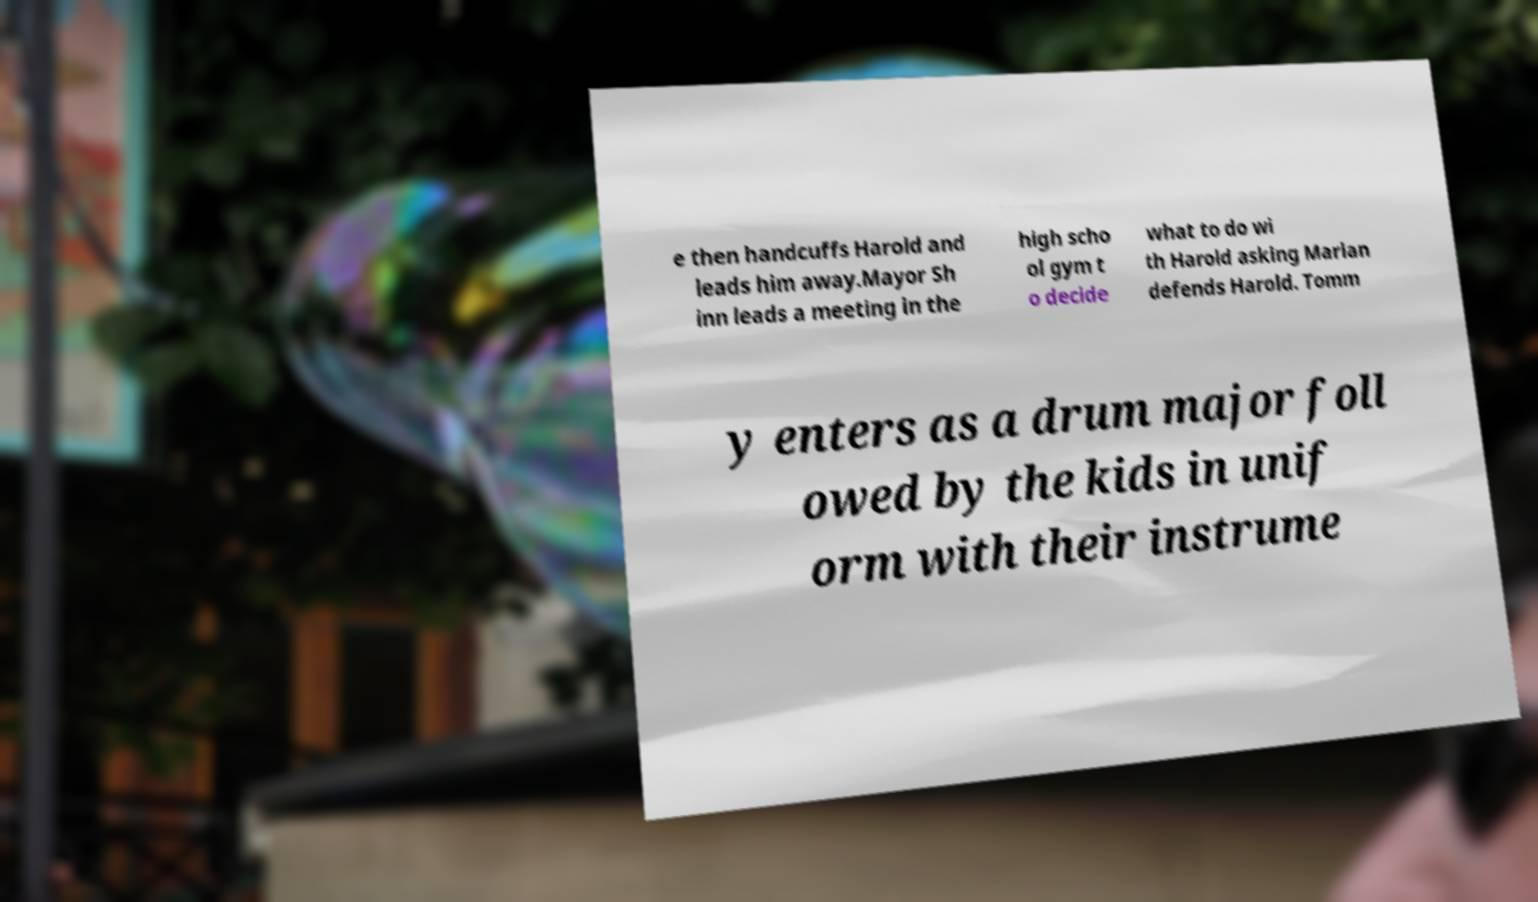Please read and relay the text visible in this image. What does it say? e then handcuffs Harold and leads him away.Mayor Sh inn leads a meeting in the high scho ol gym t o decide what to do wi th Harold asking Marian defends Harold. Tomm y enters as a drum major foll owed by the kids in unif orm with their instrume 